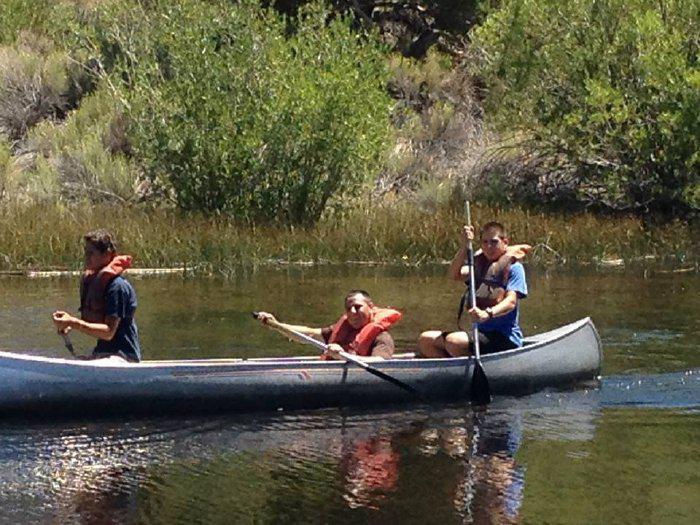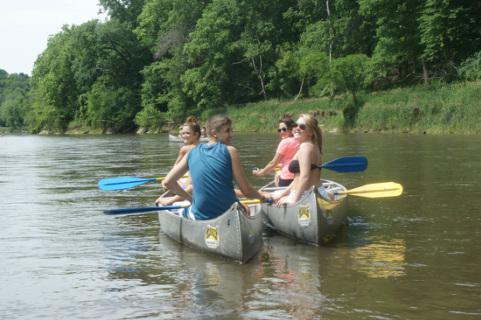The first image is the image on the left, the second image is the image on the right. Analyze the images presented: Is the assertion "The left photo shows a single silver canoe with three passengers." valid? Answer yes or no. Yes. The first image is the image on the left, the second image is the image on the right. Assess this claim about the two images: "One image shows exactly one silver canoe with 3 riders.". Correct or not? Answer yes or no. Yes. 